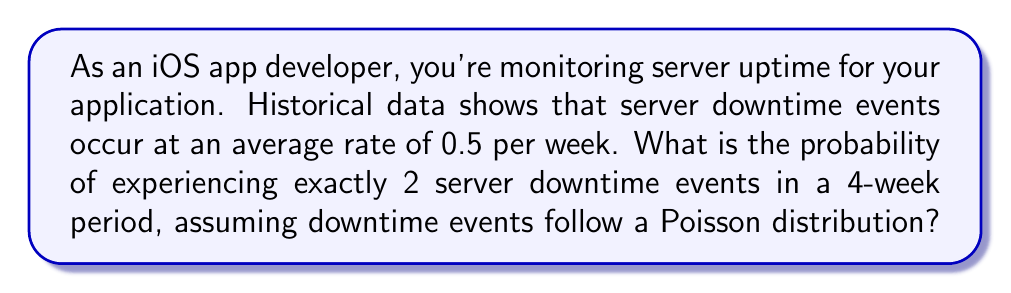What is the answer to this math problem? To solve this problem, we'll use the Poisson distribution formula:

$$P(X = k) = \frac{e^{-\lambda} \lambda^k}{k!}$$

Where:
- $\lambda$ is the average rate of events in the given time period
- $k$ is the number of events we're interested in
- $e$ is Euler's number (approximately 2.71828)

Step 1: Calculate $\lambda$ for the 4-week period
- Rate per week = 0.5
- Number of weeks = 4
- $\lambda = 0.5 \times 4 = 2$

Step 2: Plug values into the Poisson formula
- $\lambda = 2$
- $k = 2$

$$P(X = 2) = \frac{e^{-2} 2^2}{2!}$$

Step 3: Calculate each part
- $e^{-2} \approx 0.1353$
- $2^2 = 4$
- $2! = 2$

$$P(X = 2) = \frac{0.1353 \times 4}{2} \approx 0.2707$$

Step 4: Convert to percentage
$0.2707 \times 100\% \approx 27.07\%$

This result indicates that there's approximately a 27.07% chance of experiencing exactly 2 server downtime events in a 4-week period, given the specified average rate.
Answer: 27.07% 